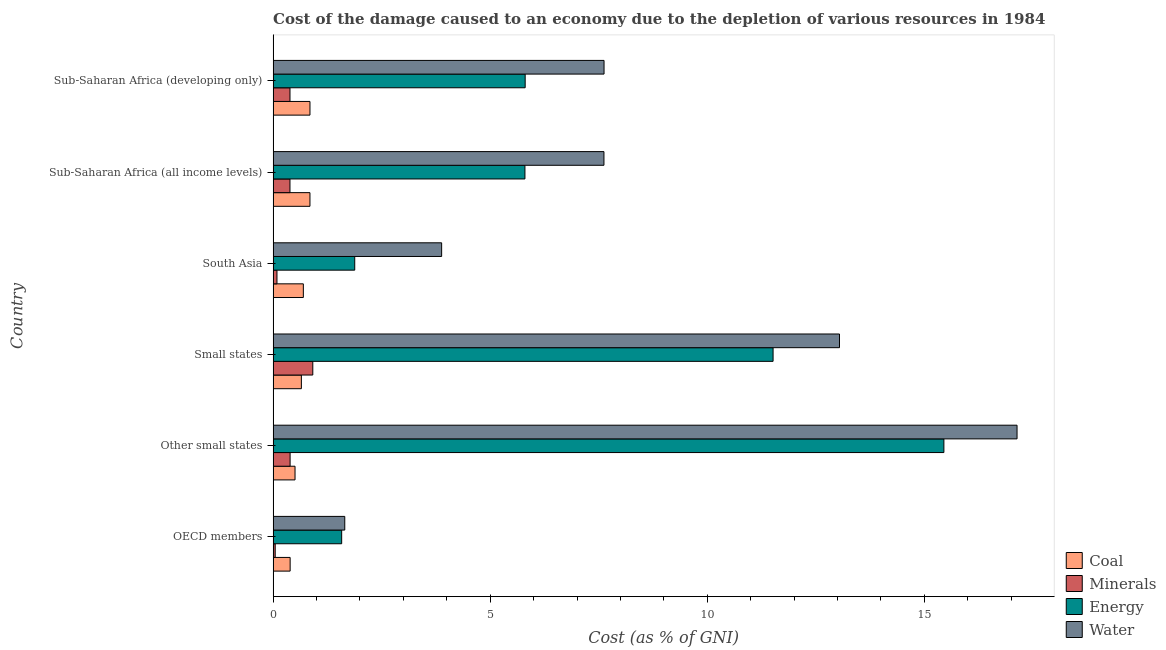How many groups of bars are there?
Give a very brief answer. 6. What is the label of the 5th group of bars from the top?
Offer a terse response. Other small states. What is the cost of damage due to depletion of energy in Other small states?
Keep it short and to the point. 15.45. Across all countries, what is the maximum cost of damage due to depletion of minerals?
Provide a short and direct response. 0.91. Across all countries, what is the minimum cost of damage due to depletion of coal?
Offer a very short reply. 0.39. In which country was the cost of damage due to depletion of coal maximum?
Make the answer very short. Sub-Saharan Africa (developing only). In which country was the cost of damage due to depletion of water minimum?
Offer a very short reply. OECD members. What is the total cost of damage due to depletion of water in the graph?
Make the answer very short. 50.96. What is the difference between the cost of damage due to depletion of water in OECD members and that in Small states?
Make the answer very short. -11.4. What is the difference between the cost of damage due to depletion of minerals in OECD members and the cost of damage due to depletion of coal in Other small states?
Your answer should be very brief. -0.46. What is the average cost of damage due to depletion of minerals per country?
Offer a very short reply. 0.37. What is the difference between the cost of damage due to depletion of minerals and cost of damage due to depletion of water in Sub-Saharan Africa (developing only)?
Your answer should be very brief. -7.23. In how many countries, is the cost of damage due to depletion of coal greater than 1 %?
Ensure brevity in your answer.  0. What is the ratio of the cost of damage due to depletion of energy in Small states to that in Sub-Saharan Africa (developing only)?
Provide a short and direct response. 1.98. Is the difference between the cost of damage due to depletion of coal in Other small states and Sub-Saharan Africa (developing only) greater than the difference between the cost of damage due to depletion of energy in Other small states and Sub-Saharan Africa (developing only)?
Offer a terse response. No. What is the difference between the highest and the second highest cost of damage due to depletion of water?
Make the answer very short. 4.09. What is the difference between the highest and the lowest cost of damage due to depletion of coal?
Make the answer very short. 0.46. In how many countries, is the cost of damage due to depletion of water greater than the average cost of damage due to depletion of water taken over all countries?
Offer a terse response. 2. Is the sum of the cost of damage due to depletion of coal in Other small states and South Asia greater than the maximum cost of damage due to depletion of water across all countries?
Give a very brief answer. No. What does the 4th bar from the top in Other small states represents?
Provide a short and direct response. Coal. What does the 1st bar from the bottom in OECD members represents?
Your answer should be very brief. Coal. Is it the case that in every country, the sum of the cost of damage due to depletion of coal and cost of damage due to depletion of minerals is greater than the cost of damage due to depletion of energy?
Make the answer very short. No. How many countries are there in the graph?
Provide a succinct answer. 6. Are the values on the major ticks of X-axis written in scientific E-notation?
Your response must be concise. No. How many legend labels are there?
Keep it short and to the point. 4. What is the title of the graph?
Offer a terse response. Cost of the damage caused to an economy due to the depletion of various resources in 1984 . Does "Corruption" appear as one of the legend labels in the graph?
Offer a very short reply. No. What is the label or title of the X-axis?
Give a very brief answer. Cost (as % of GNI). What is the label or title of the Y-axis?
Give a very brief answer. Country. What is the Cost (as % of GNI) in Coal in OECD members?
Keep it short and to the point. 0.39. What is the Cost (as % of GNI) in Minerals in OECD members?
Your response must be concise. 0.05. What is the Cost (as % of GNI) in Energy in OECD members?
Provide a short and direct response. 1.58. What is the Cost (as % of GNI) of Water in OECD members?
Keep it short and to the point. 1.65. What is the Cost (as % of GNI) in Coal in Other small states?
Your answer should be very brief. 0.5. What is the Cost (as % of GNI) in Minerals in Other small states?
Make the answer very short. 0.39. What is the Cost (as % of GNI) in Energy in Other small states?
Provide a succinct answer. 15.45. What is the Cost (as % of GNI) of Water in Other small states?
Provide a succinct answer. 17.14. What is the Cost (as % of GNI) in Coal in Small states?
Offer a terse response. 0.65. What is the Cost (as % of GNI) in Minerals in Small states?
Offer a very short reply. 0.91. What is the Cost (as % of GNI) in Energy in Small states?
Your response must be concise. 11.52. What is the Cost (as % of GNI) of Water in Small states?
Your answer should be very brief. 13.05. What is the Cost (as % of GNI) of Coal in South Asia?
Offer a terse response. 0.7. What is the Cost (as % of GNI) in Minerals in South Asia?
Offer a terse response. 0.09. What is the Cost (as % of GNI) in Energy in South Asia?
Keep it short and to the point. 1.88. What is the Cost (as % of GNI) of Water in South Asia?
Provide a short and direct response. 3.88. What is the Cost (as % of GNI) in Coal in Sub-Saharan Africa (all income levels)?
Your answer should be compact. 0.85. What is the Cost (as % of GNI) of Minerals in Sub-Saharan Africa (all income levels)?
Provide a succinct answer. 0.39. What is the Cost (as % of GNI) in Energy in Sub-Saharan Africa (all income levels)?
Ensure brevity in your answer.  5.8. What is the Cost (as % of GNI) of Water in Sub-Saharan Africa (all income levels)?
Provide a short and direct response. 7.62. What is the Cost (as % of GNI) in Coal in Sub-Saharan Africa (developing only)?
Ensure brevity in your answer.  0.85. What is the Cost (as % of GNI) of Minerals in Sub-Saharan Africa (developing only)?
Provide a short and direct response. 0.39. What is the Cost (as % of GNI) of Energy in Sub-Saharan Africa (developing only)?
Make the answer very short. 5.81. What is the Cost (as % of GNI) of Water in Sub-Saharan Africa (developing only)?
Ensure brevity in your answer.  7.62. Across all countries, what is the maximum Cost (as % of GNI) in Coal?
Offer a terse response. 0.85. Across all countries, what is the maximum Cost (as % of GNI) in Minerals?
Offer a terse response. 0.91. Across all countries, what is the maximum Cost (as % of GNI) of Energy?
Offer a very short reply. 15.45. Across all countries, what is the maximum Cost (as % of GNI) in Water?
Provide a succinct answer. 17.14. Across all countries, what is the minimum Cost (as % of GNI) in Coal?
Provide a succinct answer. 0.39. Across all countries, what is the minimum Cost (as % of GNI) in Minerals?
Your response must be concise. 0.05. Across all countries, what is the minimum Cost (as % of GNI) in Energy?
Provide a succinct answer. 1.58. Across all countries, what is the minimum Cost (as % of GNI) in Water?
Provide a succinct answer. 1.65. What is the total Cost (as % of GNI) in Coal in the graph?
Your response must be concise. 3.94. What is the total Cost (as % of GNI) of Minerals in the graph?
Your response must be concise. 2.22. What is the total Cost (as % of GNI) of Energy in the graph?
Give a very brief answer. 42.03. What is the total Cost (as % of GNI) in Water in the graph?
Your answer should be compact. 50.96. What is the difference between the Cost (as % of GNI) of Coal in OECD members and that in Other small states?
Your response must be concise. -0.11. What is the difference between the Cost (as % of GNI) in Minerals in OECD members and that in Other small states?
Offer a terse response. -0.34. What is the difference between the Cost (as % of GNI) in Energy in OECD members and that in Other small states?
Make the answer very short. -13.87. What is the difference between the Cost (as % of GNI) in Water in OECD members and that in Other small states?
Ensure brevity in your answer.  -15.49. What is the difference between the Cost (as % of GNI) of Coal in OECD members and that in Small states?
Provide a succinct answer. -0.26. What is the difference between the Cost (as % of GNI) in Minerals in OECD members and that in Small states?
Provide a succinct answer. -0.87. What is the difference between the Cost (as % of GNI) in Energy in OECD members and that in Small states?
Your answer should be compact. -9.94. What is the difference between the Cost (as % of GNI) of Water in OECD members and that in Small states?
Provide a short and direct response. -11.4. What is the difference between the Cost (as % of GNI) in Coal in OECD members and that in South Asia?
Your answer should be very brief. -0.3. What is the difference between the Cost (as % of GNI) of Minerals in OECD members and that in South Asia?
Give a very brief answer. -0.04. What is the difference between the Cost (as % of GNI) in Energy in OECD members and that in South Asia?
Provide a succinct answer. -0.3. What is the difference between the Cost (as % of GNI) of Water in OECD members and that in South Asia?
Provide a succinct answer. -2.23. What is the difference between the Cost (as % of GNI) in Coal in OECD members and that in Sub-Saharan Africa (all income levels)?
Offer a very short reply. -0.46. What is the difference between the Cost (as % of GNI) of Minerals in OECD members and that in Sub-Saharan Africa (all income levels)?
Provide a succinct answer. -0.34. What is the difference between the Cost (as % of GNI) in Energy in OECD members and that in Sub-Saharan Africa (all income levels)?
Offer a very short reply. -4.22. What is the difference between the Cost (as % of GNI) of Water in OECD members and that in Sub-Saharan Africa (all income levels)?
Provide a succinct answer. -5.97. What is the difference between the Cost (as % of GNI) in Coal in OECD members and that in Sub-Saharan Africa (developing only)?
Keep it short and to the point. -0.46. What is the difference between the Cost (as % of GNI) of Minerals in OECD members and that in Sub-Saharan Africa (developing only)?
Make the answer very short. -0.34. What is the difference between the Cost (as % of GNI) of Energy in OECD members and that in Sub-Saharan Africa (developing only)?
Keep it short and to the point. -4.23. What is the difference between the Cost (as % of GNI) of Water in OECD members and that in Sub-Saharan Africa (developing only)?
Your answer should be very brief. -5.97. What is the difference between the Cost (as % of GNI) in Coal in Other small states and that in Small states?
Keep it short and to the point. -0.15. What is the difference between the Cost (as % of GNI) in Minerals in Other small states and that in Small states?
Provide a short and direct response. -0.52. What is the difference between the Cost (as % of GNI) in Energy in Other small states and that in Small states?
Ensure brevity in your answer.  3.93. What is the difference between the Cost (as % of GNI) in Water in Other small states and that in Small states?
Your answer should be compact. 4.09. What is the difference between the Cost (as % of GNI) in Coal in Other small states and that in South Asia?
Provide a succinct answer. -0.19. What is the difference between the Cost (as % of GNI) in Minerals in Other small states and that in South Asia?
Provide a succinct answer. 0.3. What is the difference between the Cost (as % of GNI) of Energy in Other small states and that in South Asia?
Offer a terse response. 13.57. What is the difference between the Cost (as % of GNI) in Water in Other small states and that in South Asia?
Provide a succinct answer. 13.25. What is the difference between the Cost (as % of GNI) in Coal in Other small states and that in Sub-Saharan Africa (all income levels)?
Keep it short and to the point. -0.34. What is the difference between the Cost (as % of GNI) in Minerals in Other small states and that in Sub-Saharan Africa (all income levels)?
Your response must be concise. 0. What is the difference between the Cost (as % of GNI) in Energy in Other small states and that in Sub-Saharan Africa (all income levels)?
Ensure brevity in your answer.  9.65. What is the difference between the Cost (as % of GNI) in Water in Other small states and that in Sub-Saharan Africa (all income levels)?
Offer a terse response. 9.52. What is the difference between the Cost (as % of GNI) in Coal in Other small states and that in Sub-Saharan Africa (developing only)?
Your answer should be compact. -0.34. What is the difference between the Cost (as % of GNI) of Minerals in Other small states and that in Sub-Saharan Africa (developing only)?
Your answer should be very brief. 0. What is the difference between the Cost (as % of GNI) of Energy in Other small states and that in Sub-Saharan Africa (developing only)?
Your answer should be very brief. 9.65. What is the difference between the Cost (as % of GNI) in Water in Other small states and that in Sub-Saharan Africa (developing only)?
Your response must be concise. 9.51. What is the difference between the Cost (as % of GNI) of Coal in Small states and that in South Asia?
Ensure brevity in your answer.  -0.05. What is the difference between the Cost (as % of GNI) in Minerals in Small states and that in South Asia?
Keep it short and to the point. 0.83. What is the difference between the Cost (as % of GNI) in Energy in Small states and that in South Asia?
Provide a short and direct response. 9.64. What is the difference between the Cost (as % of GNI) of Water in Small states and that in South Asia?
Make the answer very short. 9.17. What is the difference between the Cost (as % of GNI) of Coal in Small states and that in Sub-Saharan Africa (all income levels)?
Offer a very short reply. -0.2. What is the difference between the Cost (as % of GNI) in Minerals in Small states and that in Sub-Saharan Africa (all income levels)?
Offer a terse response. 0.53. What is the difference between the Cost (as % of GNI) of Energy in Small states and that in Sub-Saharan Africa (all income levels)?
Make the answer very short. 5.72. What is the difference between the Cost (as % of GNI) in Water in Small states and that in Sub-Saharan Africa (all income levels)?
Ensure brevity in your answer.  5.43. What is the difference between the Cost (as % of GNI) in Coal in Small states and that in Sub-Saharan Africa (developing only)?
Your answer should be compact. -0.2. What is the difference between the Cost (as % of GNI) in Minerals in Small states and that in Sub-Saharan Africa (developing only)?
Provide a succinct answer. 0.53. What is the difference between the Cost (as % of GNI) in Energy in Small states and that in Sub-Saharan Africa (developing only)?
Provide a short and direct response. 5.71. What is the difference between the Cost (as % of GNI) of Water in Small states and that in Sub-Saharan Africa (developing only)?
Offer a terse response. 5.42. What is the difference between the Cost (as % of GNI) in Coal in South Asia and that in Sub-Saharan Africa (all income levels)?
Offer a very short reply. -0.15. What is the difference between the Cost (as % of GNI) of Minerals in South Asia and that in Sub-Saharan Africa (all income levels)?
Provide a short and direct response. -0.3. What is the difference between the Cost (as % of GNI) of Energy in South Asia and that in Sub-Saharan Africa (all income levels)?
Keep it short and to the point. -3.92. What is the difference between the Cost (as % of GNI) in Water in South Asia and that in Sub-Saharan Africa (all income levels)?
Offer a terse response. -3.74. What is the difference between the Cost (as % of GNI) in Coal in South Asia and that in Sub-Saharan Africa (developing only)?
Give a very brief answer. -0.15. What is the difference between the Cost (as % of GNI) in Minerals in South Asia and that in Sub-Saharan Africa (developing only)?
Your answer should be very brief. -0.3. What is the difference between the Cost (as % of GNI) in Energy in South Asia and that in Sub-Saharan Africa (developing only)?
Your answer should be compact. -3.93. What is the difference between the Cost (as % of GNI) of Water in South Asia and that in Sub-Saharan Africa (developing only)?
Offer a terse response. -3.74. What is the difference between the Cost (as % of GNI) in Coal in Sub-Saharan Africa (all income levels) and that in Sub-Saharan Africa (developing only)?
Your response must be concise. -0. What is the difference between the Cost (as % of GNI) of Minerals in Sub-Saharan Africa (all income levels) and that in Sub-Saharan Africa (developing only)?
Give a very brief answer. -0. What is the difference between the Cost (as % of GNI) in Energy in Sub-Saharan Africa (all income levels) and that in Sub-Saharan Africa (developing only)?
Your answer should be very brief. -0.01. What is the difference between the Cost (as % of GNI) of Water in Sub-Saharan Africa (all income levels) and that in Sub-Saharan Africa (developing only)?
Your answer should be very brief. -0. What is the difference between the Cost (as % of GNI) in Coal in OECD members and the Cost (as % of GNI) in Energy in Other small states?
Your answer should be compact. -15.06. What is the difference between the Cost (as % of GNI) in Coal in OECD members and the Cost (as % of GNI) in Water in Other small states?
Offer a terse response. -16.74. What is the difference between the Cost (as % of GNI) of Minerals in OECD members and the Cost (as % of GNI) of Energy in Other small states?
Give a very brief answer. -15.4. What is the difference between the Cost (as % of GNI) in Minerals in OECD members and the Cost (as % of GNI) in Water in Other small states?
Give a very brief answer. -17.09. What is the difference between the Cost (as % of GNI) in Energy in OECD members and the Cost (as % of GNI) in Water in Other small states?
Provide a succinct answer. -15.56. What is the difference between the Cost (as % of GNI) of Coal in OECD members and the Cost (as % of GNI) of Minerals in Small states?
Your answer should be very brief. -0.52. What is the difference between the Cost (as % of GNI) of Coal in OECD members and the Cost (as % of GNI) of Energy in Small states?
Your response must be concise. -11.12. What is the difference between the Cost (as % of GNI) of Coal in OECD members and the Cost (as % of GNI) of Water in Small states?
Provide a short and direct response. -12.65. What is the difference between the Cost (as % of GNI) in Minerals in OECD members and the Cost (as % of GNI) in Energy in Small states?
Ensure brevity in your answer.  -11.47. What is the difference between the Cost (as % of GNI) in Minerals in OECD members and the Cost (as % of GNI) in Water in Small states?
Your response must be concise. -13. What is the difference between the Cost (as % of GNI) of Energy in OECD members and the Cost (as % of GNI) of Water in Small states?
Ensure brevity in your answer.  -11.47. What is the difference between the Cost (as % of GNI) of Coal in OECD members and the Cost (as % of GNI) of Minerals in South Asia?
Provide a succinct answer. 0.3. What is the difference between the Cost (as % of GNI) of Coal in OECD members and the Cost (as % of GNI) of Energy in South Asia?
Your answer should be compact. -1.49. What is the difference between the Cost (as % of GNI) in Coal in OECD members and the Cost (as % of GNI) in Water in South Asia?
Keep it short and to the point. -3.49. What is the difference between the Cost (as % of GNI) in Minerals in OECD members and the Cost (as % of GNI) in Energy in South Asia?
Your answer should be very brief. -1.83. What is the difference between the Cost (as % of GNI) in Minerals in OECD members and the Cost (as % of GNI) in Water in South Asia?
Your response must be concise. -3.83. What is the difference between the Cost (as % of GNI) of Energy in OECD members and the Cost (as % of GNI) of Water in South Asia?
Make the answer very short. -2.3. What is the difference between the Cost (as % of GNI) of Coal in OECD members and the Cost (as % of GNI) of Minerals in Sub-Saharan Africa (all income levels)?
Your answer should be very brief. 0. What is the difference between the Cost (as % of GNI) of Coal in OECD members and the Cost (as % of GNI) of Energy in Sub-Saharan Africa (all income levels)?
Make the answer very short. -5.41. What is the difference between the Cost (as % of GNI) of Coal in OECD members and the Cost (as % of GNI) of Water in Sub-Saharan Africa (all income levels)?
Give a very brief answer. -7.23. What is the difference between the Cost (as % of GNI) of Minerals in OECD members and the Cost (as % of GNI) of Energy in Sub-Saharan Africa (all income levels)?
Provide a short and direct response. -5.75. What is the difference between the Cost (as % of GNI) in Minerals in OECD members and the Cost (as % of GNI) in Water in Sub-Saharan Africa (all income levels)?
Give a very brief answer. -7.57. What is the difference between the Cost (as % of GNI) in Energy in OECD members and the Cost (as % of GNI) in Water in Sub-Saharan Africa (all income levels)?
Offer a terse response. -6.04. What is the difference between the Cost (as % of GNI) in Coal in OECD members and the Cost (as % of GNI) in Minerals in Sub-Saharan Africa (developing only)?
Your answer should be very brief. 0. What is the difference between the Cost (as % of GNI) in Coal in OECD members and the Cost (as % of GNI) in Energy in Sub-Saharan Africa (developing only)?
Keep it short and to the point. -5.41. What is the difference between the Cost (as % of GNI) of Coal in OECD members and the Cost (as % of GNI) of Water in Sub-Saharan Africa (developing only)?
Your response must be concise. -7.23. What is the difference between the Cost (as % of GNI) in Minerals in OECD members and the Cost (as % of GNI) in Energy in Sub-Saharan Africa (developing only)?
Offer a terse response. -5.76. What is the difference between the Cost (as % of GNI) of Minerals in OECD members and the Cost (as % of GNI) of Water in Sub-Saharan Africa (developing only)?
Your answer should be compact. -7.57. What is the difference between the Cost (as % of GNI) of Energy in OECD members and the Cost (as % of GNI) of Water in Sub-Saharan Africa (developing only)?
Your response must be concise. -6.04. What is the difference between the Cost (as % of GNI) in Coal in Other small states and the Cost (as % of GNI) in Minerals in Small states?
Your response must be concise. -0.41. What is the difference between the Cost (as % of GNI) in Coal in Other small states and the Cost (as % of GNI) in Energy in Small states?
Your answer should be compact. -11.01. What is the difference between the Cost (as % of GNI) of Coal in Other small states and the Cost (as % of GNI) of Water in Small states?
Provide a succinct answer. -12.54. What is the difference between the Cost (as % of GNI) in Minerals in Other small states and the Cost (as % of GNI) in Energy in Small states?
Make the answer very short. -11.13. What is the difference between the Cost (as % of GNI) of Minerals in Other small states and the Cost (as % of GNI) of Water in Small states?
Your answer should be very brief. -12.66. What is the difference between the Cost (as % of GNI) in Energy in Other small states and the Cost (as % of GNI) in Water in Small states?
Give a very brief answer. 2.4. What is the difference between the Cost (as % of GNI) in Coal in Other small states and the Cost (as % of GNI) in Minerals in South Asia?
Offer a terse response. 0.42. What is the difference between the Cost (as % of GNI) in Coal in Other small states and the Cost (as % of GNI) in Energy in South Asia?
Offer a terse response. -1.38. What is the difference between the Cost (as % of GNI) of Coal in Other small states and the Cost (as % of GNI) of Water in South Asia?
Give a very brief answer. -3.38. What is the difference between the Cost (as % of GNI) in Minerals in Other small states and the Cost (as % of GNI) in Energy in South Asia?
Your response must be concise. -1.49. What is the difference between the Cost (as % of GNI) of Minerals in Other small states and the Cost (as % of GNI) of Water in South Asia?
Make the answer very short. -3.49. What is the difference between the Cost (as % of GNI) of Energy in Other small states and the Cost (as % of GNI) of Water in South Asia?
Make the answer very short. 11.57. What is the difference between the Cost (as % of GNI) in Coal in Other small states and the Cost (as % of GNI) in Minerals in Sub-Saharan Africa (all income levels)?
Your response must be concise. 0.12. What is the difference between the Cost (as % of GNI) in Coal in Other small states and the Cost (as % of GNI) in Energy in Sub-Saharan Africa (all income levels)?
Offer a very short reply. -5.3. What is the difference between the Cost (as % of GNI) of Coal in Other small states and the Cost (as % of GNI) of Water in Sub-Saharan Africa (all income levels)?
Offer a very short reply. -7.12. What is the difference between the Cost (as % of GNI) in Minerals in Other small states and the Cost (as % of GNI) in Energy in Sub-Saharan Africa (all income levels)?
Make the answer very short. -5.41. What is the difference between the Cost (as % of GNI) of Minerals in Other small states and the Cost (as % of GNI) of Water in Sub-Saharan Africa (all income levels)?
Your answer should be very brief. -7.23. What is the difference between the Cost (as % of GNI) in Energy in Other small states and the Cost (as % of GNI) in Water in Sub-Saharan Africa (all income levels)?
Your answer should be compact. 7.83. What is the difference between the Cost (as % of GNI) in Coal in Other small states and the Cost (as % of GNI) in Minerals in Sub-Saharan Africa (developing only)?
Offer a very short reply. 0.12. What is the difference between the Cost (as % of GNI) of Coal in Other small states and the Cost (as % of GNI) of Energy in Sub-Saharan Africa (developing only)?
Your answer should be very brief. -5.3. What is the difference between the Cost (as % of GNI) of Coal in Other small states and the Cost (as % of GNI) of Water in Sub-Saharan Africa (developing only)?
Keep it short and to the point. -7.12. What is the difference between the Cost (as % of GNI) in Minerals in Other small states and the Cost (as % of GNI) in Energy in Sub-Saharan Africa (developing only)?
Keep it short and to the point. -5.42. What is the difference between the Cost (as % of GNI) in Minerals in Other small states and the Cost (as % of GNI) in Water in Sub-Saharan Africa (developing only)?
Provide a succinct answer. -7.23. What is the difference between the Cost (as % of GNI) of Energy in Other small states and the Cost (as % of GNI) of Water in Sub-Saharan Africa (developing only)?
Ensure brevity in your answer.  7.83. What is the difference between the Cost (as % of GNI) of Coal in Small states and the Cost (as % of GNI) of Minerals in South Asia?
Provide a short and direct response. 0.56. What is the difference between the Cost (as % of GNI) in Coal in Small states and the Cost (as % of GNI) in Energy in South Asia?
Your response must be concise. -1.23. What is the difference between the Cost (as % of GNI) in Coal in Small states and the Cost (as % of GNI) in Water in South Asia?
Your response must be concise. -3.23. What is the difference between the Cost (as % of GNI) of Minerals in Small states and the Cost (as % of GNI) of Energy in South Asia?
Make the answer very short. -0.97. What is the difference between the Cost (as % of GNI) of Minerals in Small states and the Cost (as % of GNI) of Water in South Asia?
Offer a very short reply. -2.97. What is the difference between the Cost (as % of GNI) of Energy in Small states and the Cost (as % of GNI) of Water in South Asia?
Your answer should be very brief. 7.63. What is the difference between the Cost (as % of GNI) of Coal in Small states and the Cost (as % of GNI) of Minerals in Sub-Saharan Africa (all income levels)?
Make the answer very short. 0.26. What is the difference between the Cost (as % of GNI) in Coal in Small states and the Cost (as % of GNI) in Energy in Sub-Saharan Africa (all income levels)?
Ensure brevity in your answer.  -5.15. What is the difference between the Cost (as % of GNI) in Coal in Small states and the Cost (as % of GNI) in Water in Sub-Saharan Africa (all income levels)?
Ensure brevity in your answer.  -6.97. What is the difference between the Cost (as % of GNI) in Minerals in Small states and the Cost (as % of GNI) in Energy in Sub-Saharan Africa (all income levels)?
Offer a very short reply. -4.89. What is the difference between the Cost (as % of GNI) in Minerals in Small states and the Cost (as % of GNI) in Water in Sub-Saharan Africa (all income levels)?
Make the answer very short. -6.71. What is the difference between the Cost (as % of GNI) in Energy in Small states and the Cost (as % of GNI) in Water in Sub-Saharan Africa (all income levels)?
Ensure brevity in your answer.  3.9. What is the difference between the Cost (as % of GNI) of Coal in Small states and the Cost (as % of GNI) of Minerals in Sub-Saharan Africa (developing only)?
Your answer should be compact. 0.26. What is the difference between the Cost (as % of GNI) of Coal in Small states and the Cost (as % of GNI) of Energy in Sub-Saharan Africa (developing only)?
Give a very brief answer. -5.16. What is the difference between the Cost (as % of GNI) of Coal in Small states and the Cost (as % of GNI) of Water in Sub-Saharan Africa (developing only)?
Your response must be concise. -6.97. What is the difference between the Cost (as % of GNI) of Minerals in Small states and the Cost (as % of GNI) of Energy in Sub-Saharan Africa (developing only)?
Make the answer very short. -4.89. What is the difference between the Cost (as % of GNI) of Minerals in Small states and the Cost (as % of GNI) of Water in Sub-Saharan Africa (developing only)?
Your answer should be very brief. -6.71. What is the difference between the Cost (as % of GNI) of Energy in Small states and the Cost (as % of GNI) of Water in Sub-Saharan Africa (developing only)?
Offer a terse response. 3.89. What is the difference between the Cost (as % of GNI) of Coal in South Asia and the Cost (as % of GNI) of Minerals in Sub-Saharan Africa (all income levels)?
Provide a succinct answer. 0.31. What is the difference between the Cost (as % of GNI) of Coal in South Asia and the Cost (as % of GNI) of Energy in Sub-Saharan Africa (all income levels)?
Ensure brevity in your answer.  -5.1. What is the difference between the Cost (as % of GNI) in Coal in South Asia and the Cost (as % of GNI) in Water in Sub-Saharan Africa (all income levels)?
Ensure brevity in your answer.  -6.92. What is the difference between the Cost (as % of GNI) of Minerals in South Asia and the Cost (as % of GNI) of Energy in Sub-Saharan Africa (all income levels)?
Offer a terse response. -5.71. What is the difference between the Cost (as % of GNI) in Minerals in South Asia and the Cost (as % of GNI) in Water in Sub-Saharan Africa (all income levels)?
Make the answer very short. -7.53. What is the difference between the Cost (as % of GNI) of Energy in South Asia and the Cost (as % of GNI) of Water in Sub-Saharan Africa (all income levels)?
Your answer should be very brief. -5.74. What is the difference between the Cost (as % of GNI) of Coal in South Asia and the Cost (as % of GNI) of Minerals in Sub-Saharan Africa (developing only)?
Provide a short and direct response. 0.31. What is the difference between the Cost (as % of GNI) in Coal in South Asia and the Cost (as % of GNI) in Energy in Sub-Saharan Africa (developing only)?
Make the answer very short. -5.11. What is the difference between the Cost (as % of GNI) of Coal in South Asia and the Cost (as % of GNI) of Water in Sub-Saharan Africa (developing only)?
Your answer should be compact. -6.93. What is the difference between the Cost (as % of GNI) of Minerals in South Asia and the Cost (as % of GNI) of Energy in Sub-Saharan Africa (developing only)?
Give a very brief answer. -5.72. What is the difference between the Cost (as % of GNI) in Minerals in South Asia and the Cost (as % of GNI) in Water in Sub-Saharan Africa (developing only)?
Make the answer very short. -7.53. What is the difference between the Cost (as % of GNI) of Energy in South Asia and the Cost (as % of GNI) of Water in Sub-Saharan Africa (developing only)?
Your answer should be very brief. -5.74. What is the difference between the Cost (as % of GNI) in Coal in Sub-Saharan Africa (all income levels) and the Cost (as % of GNI) in Minerals in Sub-Saharan Africa (developing only)?
Provide a short and direct response. 0.46. What is the difference between the Cost (as % of GNI) of Coal in Sub-Saharan Africa (all income levels) and the Cost (as % of GNI) of Energy in Sub-Saharan Africa (developing only)?
Keep it short and to the point. -4.96. What is the difference between the Cost (as % of GNI) in Coal in Sub-Saharan Africa (all income levels) and the Cost (as % of GNI) in Water in Sub-Saharan Africa (developing only)?
Give a very brief answer. -6.77. What is the difference between the Cost (as % of GNI) in Minerals in Sub-Saharan Africa (all income levels) and the Cost (as % of GNI) in Energy in Sub-Saharan Africa (developing only)?
Your answer should be very brief. -5.42. What is the difference between the Cost (as % of GNI) of Minerals in Sub-Saharan Africa (all income levels) and the Cost (as % of GNI) of Water in Sub-Saharan Africa (developing only)?
Your answer should be compact. -7.23. What is the difference between the Cost (as % of GNI) of Energy in Sub-Saharan Africa (all income levels) and the Cost (as % of GNI) of Water in Sub-Saharan Africa (developing only)?
Provide a succinct answer. -1.82. What is the average Cost (as % of GNI) in Coal per country?
Your answer should be very brief. 0.66. What is the average Cost (as % of GNI) of Minerals per country?
Offer a very short reply. 0.37. What is the average Cost (as % of GNI) in Energy per country?
Offer a terse response. 7.01. What is the average Cost (as % of GNI) of Water per country?
Ensure brevity in your answer.  8.49. What is the difference between the Cost (as % of GNI) of Coal and Cost (as % of GNI) of Minerals in OECD members?
Give a very brief answer. 0.34. What is the difference between the Cost (as % of GNI) in Coal and Cost (as % of GNI) in Energy in OECD members?
Keep it short and to the point. -1.19. What is the difference between the Cost (as % of GNI) in Coal and Cost (as % of GNI) in Water in OECD members?
Offer a very short reply. -1.26. What is the difference between the Cost (as % of GNI) of Minerals and Cost (as % of GNI) of Energy in OECD members?
Your response must be concise. -1.53. What is the difference between the Cost (as % of GNI) in Minerals and Cost (as % of GNI) in Water in OECD members?
Provide a short and direct response. -1.6. What is the difference between the Cost (as % of GNI) of Energy and Cost (as % of GNI) of Water in OECD members?
Provide a short and direct response. -0.07. What is the difference between the Cost (as % of GNI) of Coal and Cost (as % of GNI) of Minerals in Other small states?
Provide a short and direct response. 0.11. What is the difference between the Cost (as % of GNI) of Coal and Cost (as % of GNI) of Energy in Other small states?
Provide a short and direct response. -14.95. What is the difference between the Cost (as % of GNI) in Coal and Cost (as % of GNI) in Water in Other small states?
Offer a terse response. -16.63. What is the difference between the Cost (as % of GNI) in Minerals and Cost (as % of GNI) in Energy in Other small states?
Your response must be concise. -15.06. What is the difference between the Cost (as % of GNI) in Minerals and Cost (as % of GNI) in Water in Other small states?
Your response must be concise. -16.75. What is the difference between the Cost (as % of GNI) in Energy and Cost (as % of GNI) in Water in Other small states?
Offer a very short reply. -1.69. What is the difference between the Cost (as % of GNI) in Coal and Cost (as % of GNI) in Minerals in Small states?
Ensure brevity in your answer.  -0.26. What is the difference between the Cost (as % of GNI) of Coal and Cost (as % of GNI) of Energy in Small states?
Provide a succinct answer. -10.87. What is the difference between the Cost (as % of GNI) in Coal and Cost (as % of GNI) in Water in Small states?
Provide a short and direct response. -12.4. What is the difference between the Cost (as % of GNI) of Minerals and Cost (as % of GNI) of Energy in Small states?
Offer a terse response. -10.6. What is the difference between the Cost (as % of GNI) of Minerals and Cost (as % of GNI) of Water in Small states?
Keep it short and to the point. -12.13. What is the difference between the Cost (as % of GNI) in Energy and Cost (as % of GNI) in Water in Small states?
Provide a short and direct response. -1.53. What is the difference between the Cost (as % of GNI) of Coal and Cost (as % of GNI) of Minerals in South Asia?
Provide a succinct answer. 0.61. What is the difference between the Cost (as % of GNI) in Coal and Cost (as % of GNI) in Energy in South Asia?
Your response must be concise. -1.18. What is the difference between the Cost (as % of GNI) of Coal and Cost (as % of GNI) of Water in South Asia?
Ensure brevity in your answer.  -3.19. What is the difference between the Cost (as % of GNI) in Minerals and Cost (as % of GNI) in Energy in South Asia?
Your answer should be very brief. -1.79. What is the difference between the Cost (as % of GNI) of Minerals and Cost (as % of GNI) of Water in South Asia?
Offer a very short reply. -3.79. What is the difference between the Cost (as % of GNI) of Energy and Cost (as % of GNI) of Water in South Asia?
Offer a terse response. -2. What is the difference between the Cost (as % of GNI) of Coal and Cost (as % of GNI) of Minerals in Sub-Saharan Africa (all income levels)?
Keep it short and to the point. 0.46. What is the difference between the Cost (as % of GNI) in Coal and Cost (as % of GNI) in Energy in Sub-Saharan Africa (all income levels)?
Your answer should be very brief. -4.95. What is the difference between the Cost (as % of GNI) of Coal and Cost (as % of GNI) of Water in Sub-Saharan Africa (all income levels)?
Your answer should be very brief. -6.77. What is the difference between the Cost (as % of GNI) of Minerals and Cost (as % of GNI) of Energy in Sub-Saharan Africa (all income levels)?
Your answer should be compact. -5.41. What is the difference between the Cost (as % of GNI) in Minerals and Cost (as % of GNI) in Water in Sub-Saharan Africa (all income levels)?
Your answer should be compact. -7.23. What is the difference between the Cost (as % of GNI) of Energy and Cost (as % of GNI) of Water in Sub-Saharan Africa (all income levels)?
Offer a very short reply. -1.82. What is the difference between the Cost (as % of GNI) of Coal and Cost (as % of GNI) of Minerals in Sub-Saharan Africa (developing only)?
Offer a terse response. 0.46. What is the difference between the Cost (as % of GNI) in Coal and Cost (as % of GNI) in Energy in Sub-Saharan Africa (developing only)?
Your response must be concise. -4.96. What is the difference between the Cost (as % of GNI) of Coal and Cost (as % of GNI) of Water in Sub-Saharan Africa (developing only)?
Provide a short and direct response. -6.77. What is the difference between the Cost (as % of GNI) of Minerals and Cost (as % of GNI) of Energy in Sub-Saharan Africa (developing only)?
Your response must be concise. -5.42. What is the difference between the Cost (as % of GNI) in Minerals and Cost (as % of GNI) in Water in Sub-Saharan Africa (developing only)?
Offer a terse response. -7.23. What is the difference between the Cost (as % of GNI) in Energy and Cost (as % of GNI) in Water in Sub-Saharan Africa (developing only)?
Offer a terse response. -1.82. What is the ratio of the Cost (as % of GNI) of Coal in OECD members to that in Other small states?
Your response must be concise. 0.78. What is the ratio of the Cost (as % of GNI) in Minerals in OECD members to that in Other small states?
Your answer should be compact. 0.12. What is the ratio of the Cost (as % of GNI) of Energy in OECD members to that in Other small states?
Make the answer very short. 0.1. What is the ratio of the Cost (as % of GNI) in Water in OECD members to that in Other small states?
Your answer should be compact. 0.1. What is the ratio of the Cost (as % of GNI) of Coal in OECD members to that in Small states?
Provide a short and direct response. 0.6. What is the ratio of the Cost (as % of GNI) of Minerals in OECD members to that in Small states?
Provide a short and direct response. 0.05. What is the ratio of the Cost (as % of GNI) of Energy in OECD members to that in Small states?
Your response must be concise. 0.14. What is the ratio of the Cost (as % of GNI) of Water in OECD members to that in Small states?
Provide a succinct answer. 0.13. What is the ratio of the Cost (as % of GNI) in Coal in OECD members to that in South Asia?
Provide a short and direct response. 0.56. What is the ratio of the Cost (as % of GNI) in Minerals in OECD members to that in South Asia?
Your response must be concise. 0.54. What is the ratio of the Cost (as % of GNI) in Energy in OECD members to that in South Asia?
Your response must be concise. 0.84. What is the ratio of the Cost (as % of GNI) of Water in OECD members to that in South Asia?
Keep it short and to the point. 0.43. What is the ratio of the Cost (as % of GNI) of Coal in OECD members to that in Sub-Saharan Africa (all income levels)?
Provide a short and direct response. 0.46. What is the ratio of the Cost (as % of GNI) in Minerals in OECD members to that in Sub-Saharan Africa (all income levels)?
Provide a short and direct response. 0.12. What is the ratio of the Cost (as % of GNI) in Energy in OECD members to that in Sub-Saharan Africa (all income levels)?
Make the answer very short. 0.27. What is the ratio of the Cost (as % of GNI) of Water in OECD members to that in Sub-Saharan Africa (all income levels)?
Make the answer very short. 0.22. What is the ratio of the Cost (as % of GNI) in Coal in OECD members to that in Sub-Saharan Africa (developing only)?
Make the answer very short. 0.46. What is the ratio of the Cost (as % of GNI) of Minerals in OECD members to that in Sub-Saharan Africa (developing only)?
Your answer should be very brief. 0.12. What is the ratio of the Cost (as % of GNI) of Energy in OECD members to that in Sub-Saharan Africa (developing only)?
Offer a very short reply. 0.27. What is the ratio of the Cost (as % of GNI) in Water in OECD members to that in Sub-Saharan Africa (developing only)?
Provide a succinct answer. 0.22. What is the ratio of the Cost (as % of GNI) in Coal in Other small states to that in Small states?
Offer a terse response. 0.78. What is the ratio of the Cost (as % of GNI) in Minerals in Other small states to that in Small states?
Your answer should be very brief. 0.43. What is the ratio of the Cost (as % of GNI) of Energy in Other small states to that in Small states?
Provide a short and direct response. 1.34. What is the ratio of the Cost (as % of GNI) of Water in Other small states to that in Small states?
Provide a short and direct response. 1.31. What is the ratio of the Cost (as % of GNI) in Coal in Other small states to that in South Asia?
Offer a very short reply. 0.72. What is the ratio of the Cost (as % of GNI) in Minerals in Other small states to that in South Asia?
Provide a succinct answer. 4.41. What is the ratio of the Cost (as % of GNI) in Energy in Other small states to that in South Asia?
Give a very brief answer. 8.22. What is the ratio of the Cost (as % of GNI) of Water in Other small states to that in South Asia?
Ensure brevity in your answer.  4.41. What is the ratio of the Cost (as % of GNI) of Coal in Other small states to that in Sub-Saharan Africa (all income levels)?
Provide a succinct answer. 0.59. What is the ratio of the Cost (as % of GNI) of Energy in Other small states to that in Sub-Saharan Africa (all income levels)?
Make the answer very short. 2.66. What is the ratio of the Cost (as % of GNI) of Water in Other small states to that in Sub-Saharan Africa (all income levels)?
Keep it short and to the point. 2.25. What is the ratio of the Cost (as % of GNI) of Coal in Other small states to that in Sub-Saharan Africa (developing only)?
Offer a very short reply. 0.59. What is the ratio of the Cost (as % of GNI) of Energy in Other small states to that in Sub-Saharan Africa (developing only)?
Provide a short and direct response. 2.66. What is the ratio of the Cost (as % of GNI) in Water in Other small states to that in Sub-Saharan Africa (developing only)?
Provide a short and direct response. 2.25. What is the ratio of the Cost (as % of GNI) in Coal in Small states to that in South Asia?
Your answer should be very brief. 0.93. What is the ratio of the Cost (as % of GNI) of Minerals in Small states to that in South Asia?
Your answer should be compact. 10.31. What is the ratio of the Cost (as % of GNI) in Energy in Small states to that in South Asia?
Provide a short and direct response. 6.13. What is the ratio of the Cost (as % of GNI) in Water in Small states to that in South Asia?
Your answer should be very brief. 3.36. What is the ratio of the Cost (as % of GNI) in Coal in Small states to that in Sub-Saharan Africa (all income levels)?
Your response must be concise. 0.77. What is the ratio of the Cost (as % of GNI) of Minerals in Small states to that in Sub-Saharan Africa (all income levels)?
Provide a succinct answer. 2.35. What is the ratio of the Cost (as % of GNI) of Energy in Small states to that in Sub-Saharan Africa (all income levels)?
Ensure brevity in your answer.  1.99. What is the ratio of the Cost (as % of GNI) of Water in Small states to that in Sub-Saharan Africa (all income levels)?
Keep it short and to the point. 1.71. What is the ratio of the Cost (as % of GNI) in Coal in Small states to that in Sub-Saharan Africa (developing only)?
Offer a terse response. 0.77. What is the ratio of the Cost (as % of GNI) of Minerals in Small states to that in Sub-Saharan Africa (developing only)?
Make the answer very short. 2.35. What is the ratio of the Cost (as % of GNI) of Energy in Small states to that in Sub-Saharan Africa (developing only)?
Make the answer very short. 1.98. What is the ratio of the Cost (as % of GNI) in Water in Small states to that in Sub-Saharan Africa (developing only)?
Keep it short and to the point. 1.71. What is the ratio of the Cost (as % of GNI) of Coal in South Asia to that in Sub-Saharan Africa (all income levels)?
Make the answer very short. 0.82. What is the ratio of the Cost (as % of GNI) of Minerals in South Asia to that in Sub-Saharan Africa (all income levels)?
Make the answer very short. 0.23. What is the ratio of the Cost (as % of GNI) of Energy in South Asia to that in Sub-Saharan Africa (all income levels)?
Provide a short and direct response. 0.32. What is the ratio of the Cost (as % of GNI) in Water in South Asia to that in Sub-Saharan Africa (all income levels)?
Offer a very short reply. 0.51. What is the ratio of the Cost (as % of GNI) of Coal in South Asia to that in Sub-Saharan Africa (developing only)?
Ensure brevity in your answer.  0.82. What is the ratio of the Cost (as % of GNI) in Minerals in South Asia to that in Sub-Saharan Africa (developing only)?
Your answer should be compact. 0.23. What is the ratio of the Cost (as % of GNI) in Energy in South Asia to that in Sub-Saharan Africa (developing only)?
Your answer should be very brief. 0.32. What is the ratio of the Cost (as % of GNI) in Water in South Asia to that in Sub-Saharan Africa (developing only)?
Your answer should be compact. 0.51. What is the difference between the highest and the second highest Cost (as % of GNI) of Minerals?
Your response must be concise. 0.52. What is the difference between the highest and the second highest Cost (as % of GNI) of Energy?
Provide a short and direct response. 3.93. What is the difference between the highest and the second highest Cost (as % of GNI) of Water?
Keep it short and to the point. 4.09. What is the difference between the highest and the lowest Cost (as % of GNI) of Coal?
Your answer should be compact. 0.46. What is the difference between the highest and the lowest Cost (as % of GNI) of Minerals?
Ensure brevity in your answer.  0.87. What is the difference between the highest and the lowest Cost (as % of GNI) in Energy?
Provide a short and direct response. 13.87. What is the difference between the highest and the lowest Cost (as % of GNI) of Water?
Offer a very short reply. 15.49. 